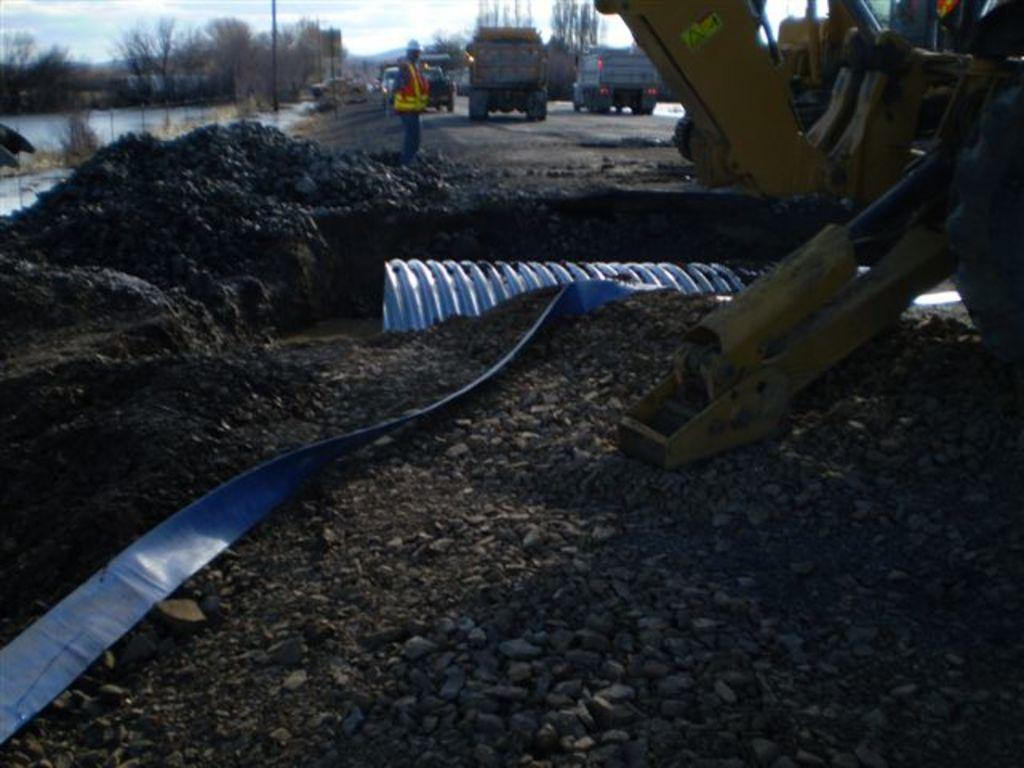What can be seen at the base of the image? The ground is visible in the image. What is located on the ground in the image? There are objects on the ground in the image. What type of transportation can be seen in the image? There are vehicles in the image. Can you describe the person in the image? There is a person in the image. What natural element is present in the image? Water is present in the image. What vertical structures can be seen in the image? There are poles in the image. What type of vegetation is visible in the image? Trees are visible in the image. What part of the natural environment is visible in the image? The sky is visible in the image. What atmospheric feature can be seen in the sky? Clouds are present in the sky. How does the quilt compare to the trees in the image? There is no quilt present in the image, so it cannot be compared to the trees. 